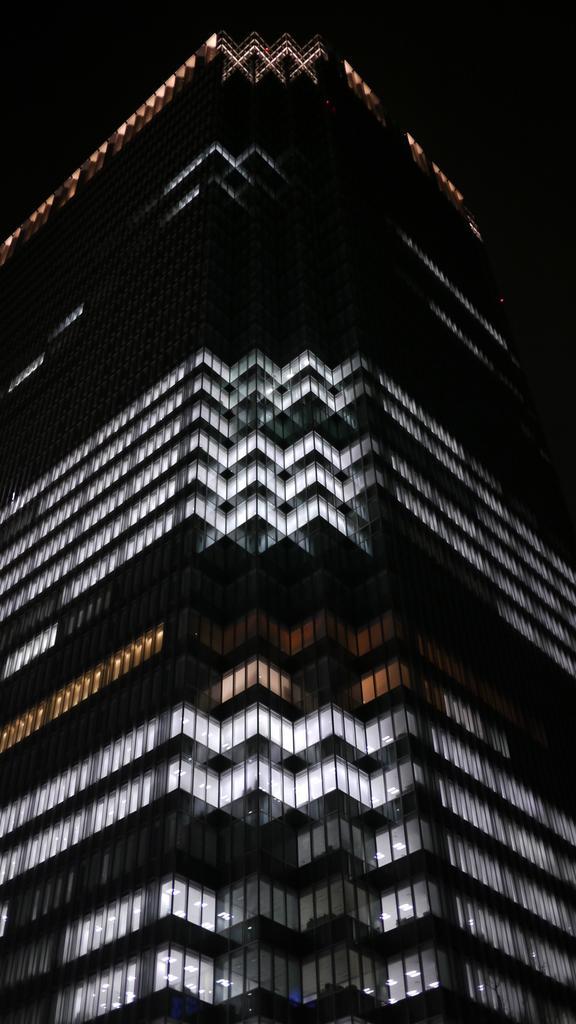Could you give a brief overview of what you see in this image? In this picture, we see a building which is in white and black color. At the top of the picture, it is black in color and this picture might be clicked in the dark. 